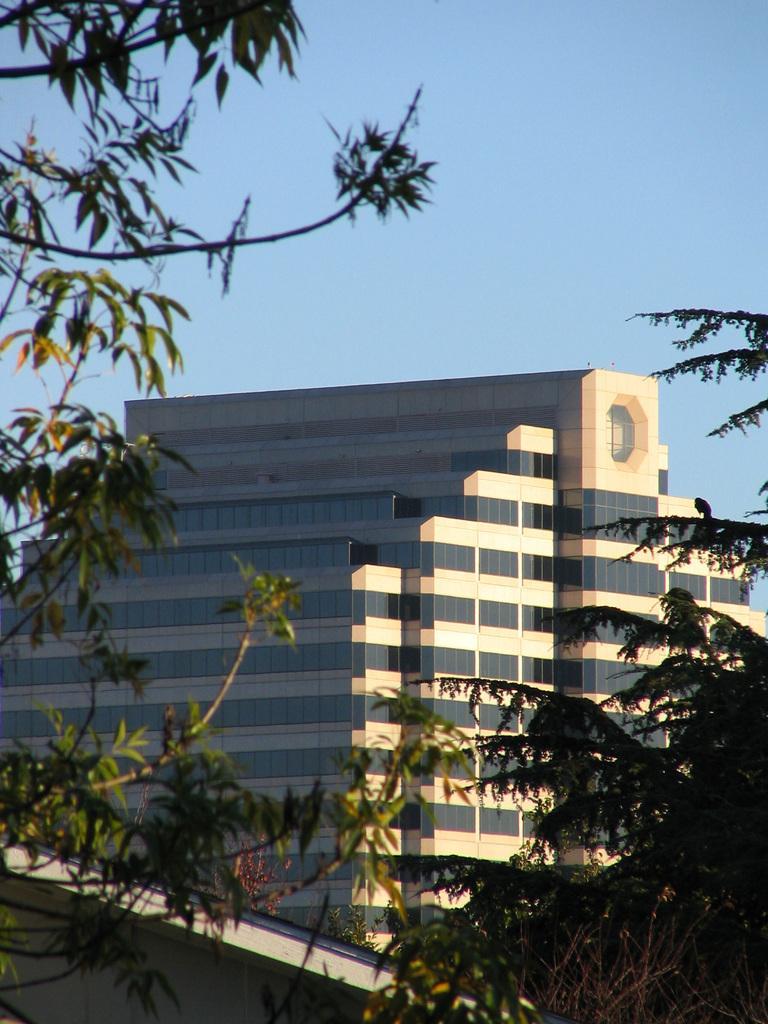In one or two sentences, can you explain what this image depicts? This image is taken outdoors. At the top of the image there is a sky. On the left and right sides of the image there are a few trees. In the middle of the image there is a building with walls, windows and a roof. 